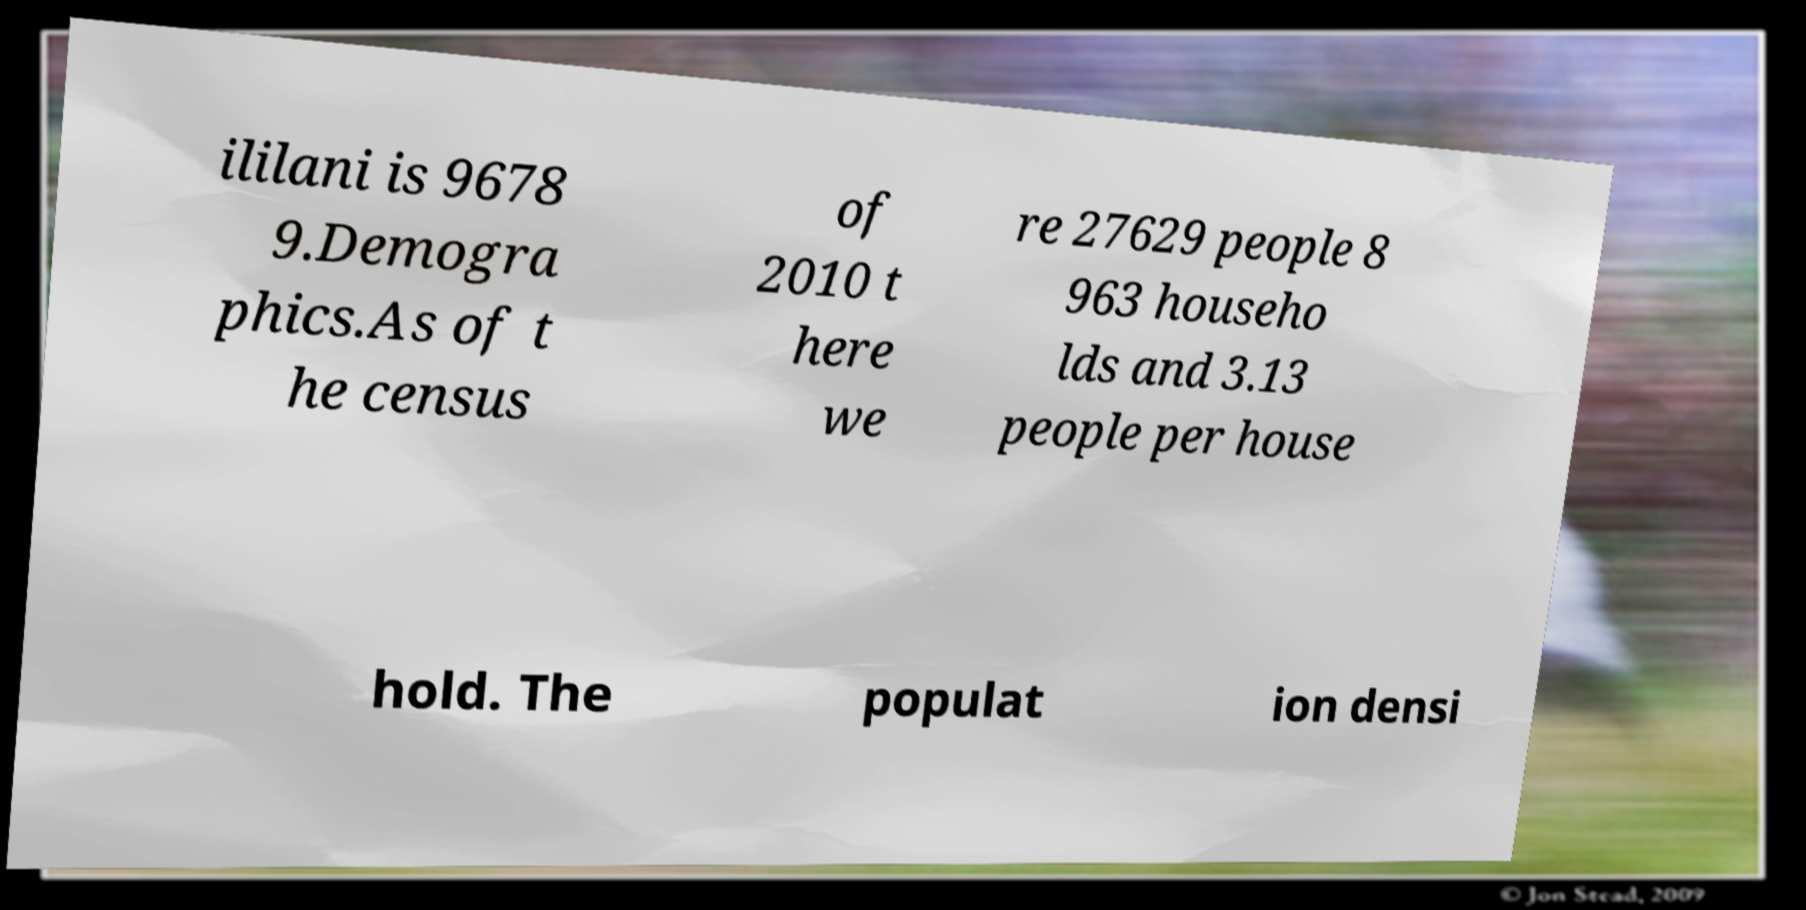Can you read and provide the text displayed in the image?This photo seems to have some interesting text. Can you extract and type it out for me? ililani is 9678 9.Demogra phics.As of t he census of 2010 t here we re 27629 people 8 963 househo lds and 3.13 people per house hold. The populat ion densi 